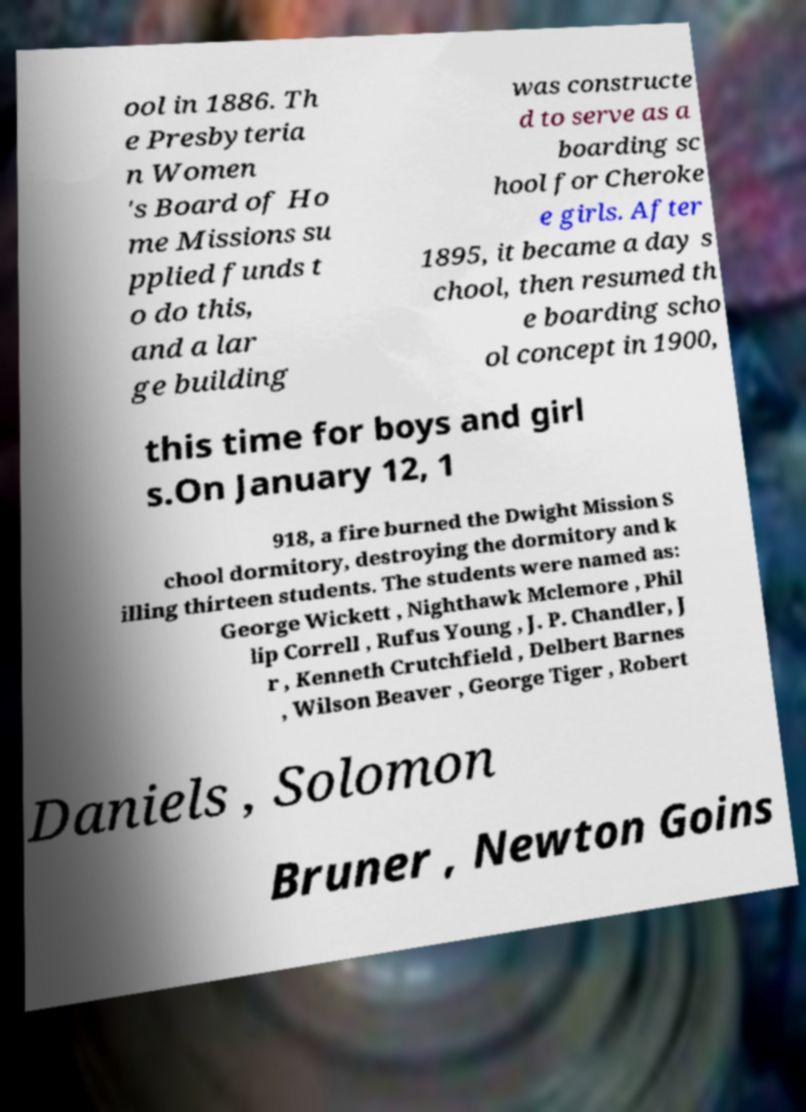Please read and relay the text visible in this image. What does it say? ool in 1886. Th e Presbyteria n Women 's Board of Ho me Missions su pplied funds t o do this, and a lar ge building was constructe d to serve as a boarding sc hool for Cheroke e girls. After 1895, it became a day s chool, then resumed th e boarding scho ol concept in 1900, this time for boys and girl s.On January 12, 1 918, a fire burned the Dwight Mission S chool dormitory, destroying the dormitory and k illing thirteen students. The students were named as: George Wickett , Nighthawk Mclemore , Phil lip Correll , Rufus Young , J. P. Chandler, J r , Kenneth Crutchfield , Delbert Barnes , Wilson Beaver , George Tiger , Robert Daniels , Solomon Bruner , Newton Goins 